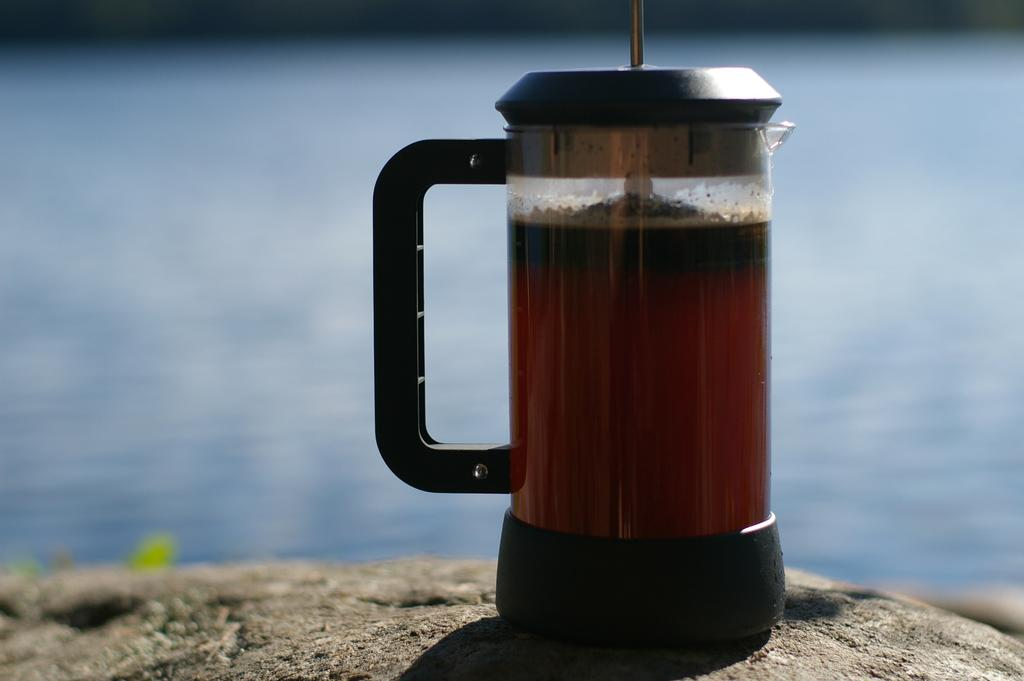What type of natural feature is present in the image? There is a lake in the image. What object can be seen on a rock surface in the image? There is a juice jar on a rock surface in the image. Can you describe the rock formation in the image? There is a rock at the bottom of the image. Where is the mom standing with her scarf in the image? There is no mom or scarf present in the image. 